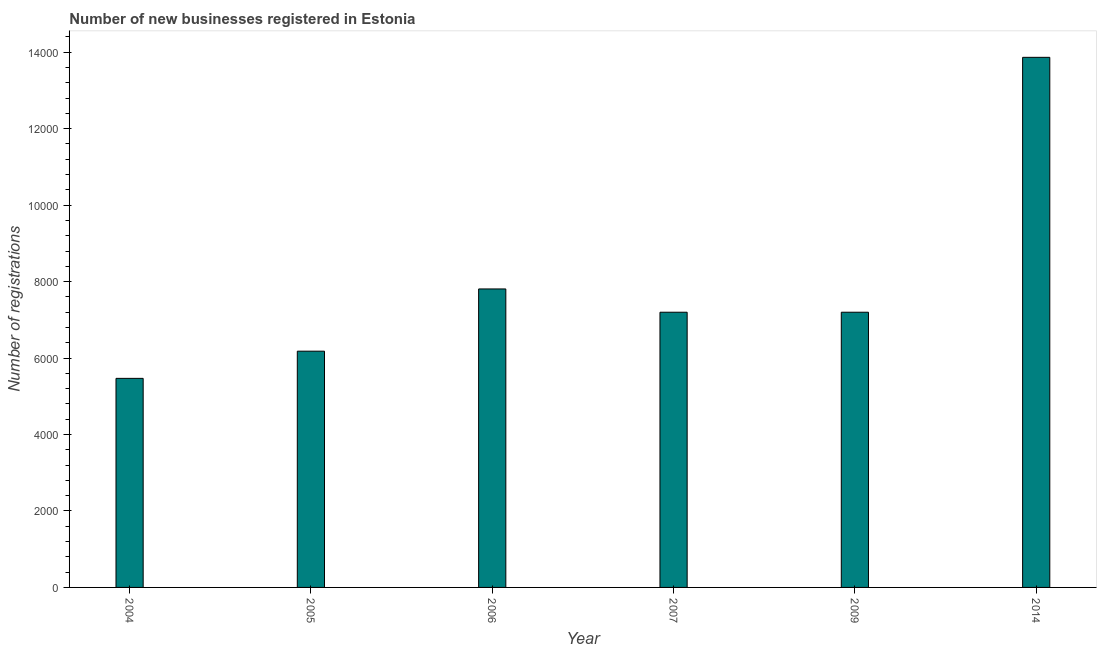Does the graph contain any zero values?
Offer a very short reply. No. What is the title of the graph?
Your response must be concise. Number of new businesses registered in Estonia. What is the label or title of the X-axis?
Your answer should be very brief. Year. What is the label or title of the Y-axis?
Your answer should be compact. Number of registrations. What is the number of new business registrations in 2007?
Your response must be concise. 7199. Across all years, what is the maximum number of new business registrations?
Give a very brief answer. 1.39e+04. Across all years, what is the minimum number of new business registrations?
Your answer should be very brief. 5469. In which year was the number of new business registrations maximum?
Make the answer very short. 2014. What is the sum of the number of new business registrations?
Your answer should be compact. 4.77e+04. What is the difference between the number of new business registrations in 2004 and 2007?
Make the answer very short. -1730. What is the average number of new business registrations per year?
Ensure brevity in your answer.  7953. What is the median number of new business registrations?
Your answer should be compact. 7199. In how many years, is the number of new business registrations greater than 8000 ?
Give a very brief answer. 1. What is the ratio of the number of new business registrations in 2004 to that in 2007?
Offer a terse response. 0.76. Is the difference between the number of new business registrations in 2006 and 2014 greater than the difference between any two years?
Your response must be concise. No. What is the difference between the highest and the second highest number of new business registrations?
Keep it short and to the point. 6059. What is the difference between the highest and the lowest number of new business registrations?
Offer a terse response. 8398. In how many years, is the number of new business registrations greater than the average number of new business registrations taken over all years?
Your answer should be very brief. 1. Are all the bars in the graph horizontal?
Give a very brief answer. No. How many years are there in the graph?
Provide a succinct answer. 6. Are the values on the major ticks of Y-axis written in scientific E-notation?
Make the answer very short. No. What is the Number of registrations in 2004?
Make the answer very short. 5469. What is the Number of registrations in 2005?
Provide a short and direct response. 6180. What is the Number of registrations of 2006?
Your answer should be very brief. 7808. What is the Number of registrations of 2007?
Provide a succinct answer. 7199. What is the Number of registrations in 2009?
Offer a terse response. 7199. What is the Number of registrations of 2014?
Offer a terse response. 1.39e+04. What is the difference between the Number of registrations in 2004 and 2005?
Your response must be concise. -711. What is the difference between the Number of registrations in 2004 and 2006?
Provide a succinct answer. -2339. What is the difference between the Number of registrations in 2004 and 2007?
Keep it short and to the point. -1730. What is the difference between the Number of registrations in 2004 and 2009?
Provide a short and direct response. -1730. What is the difference between the Number of registrations in 2004 and 2014?
Your answer should be very brief. -8398. What is the difference between the Number of registrations in 2005 and 2006?
Offer a terse response. -1628. What is the difference between the Number of registrations in 2005 and 2007?
Provide a short and direct response. -1019. What is the difference between the Number of registrations in 2005 and 2009?
Give a very brief answer. -1019. What is the difference between the Number of registrations in 2005 and 2014?
Offer a terse response. -7687. What is the difference between the Number of registrations in 2006 and 2007?
Offer a very short reply. 609. What is the difference between the Number of registrations in 2006 and 2009?
Your answer should be compact. 609. What is the difference between the Number of registrations in 2006 and 2014?
Provide a succinct answer. -6059. What is the difference between the Number of registrations in 2007 and 2014?
Your answer should be very brief. -6668. What is the difference between the Number of registrations in 2009 and 2014?
Provide a succinct answer. -6668. What is the ratio of the Number of registrations in 2004 to that in 2005?
Offer a very short reply. 0.89. What is the ratio of the Number of registrations in 2004 to that in 2006?
Give a very brief answer. 0.7. What is the ratio of the Number of registrations in 2004 to that in 2007?
Ensure brevity in your answer.  0.76. What is the ratio of the Number of registrations in 2004 to that in 2009?
Provide a short and direct response. 0.76. What is the ratio of the Number of registrations in 2004 to that in 2014?
Provide a succinct answer. 0.39. What is the ratio of the Number of registrations in 2005 to that in 2006?
Make the answer very short. 0.79. What is the ratio of the Number of registrations in 2005 to that in 2007?
Offer a very short reply. 0.86. What is the ratio of the Number of registrations in 2005 to that in 2009?
Your answer should be compact. 0.86. What is the ratio of the Number of registrations in 2005 to that in 2014?
Make the answer very short. 0.45. What is the ratio of the Number of registrations in 2006 to that in 2007?
Offer a terse response. 1.08. What is the ratio of the Number of registrations in 2006 to that in 2009?
Make the answer very short. 1.08. What is the ratio of the Number of registrations in 2006 to that in 2014?
Offer a terse response. 0.56. What is the ratio of the Number of registrations in 2007 to that in 2014?
Provide a succinct answer. 0.52. What is the ratio of the Number of registrations in 2009 to that in 2014?
Your answer should be compact. 0.52. 